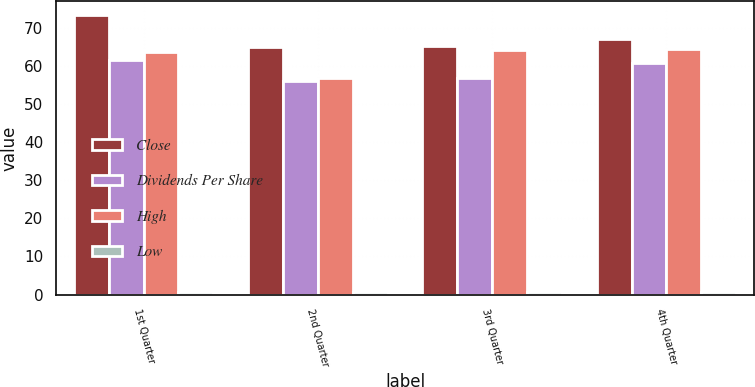Convert chart. <chart><loc_0><loc_0><loc_500><loc_500><stacked_bar_chart><ecel><fcel>1st Quarter<fcel>2nd Quarter<fcel>3rd Quarter<fcel>4th Quarter<nl><fcel>Close<fcel>73.31<fcel>64.95<fcel>65.23<fcel>67.02<nl><fcel>Dividends Per Share<fcel>61.53<fcel>56.01<fcel>56.77<fcel>60.7<nl><fcel>High<fcel>63.75<fcel>56.89<fcel>64.14<fcel>64.48<nl><fcel>Low<fcel>0.59<fcel>0.59<fcel>0.59<fcel>0.62<nl></chart> 